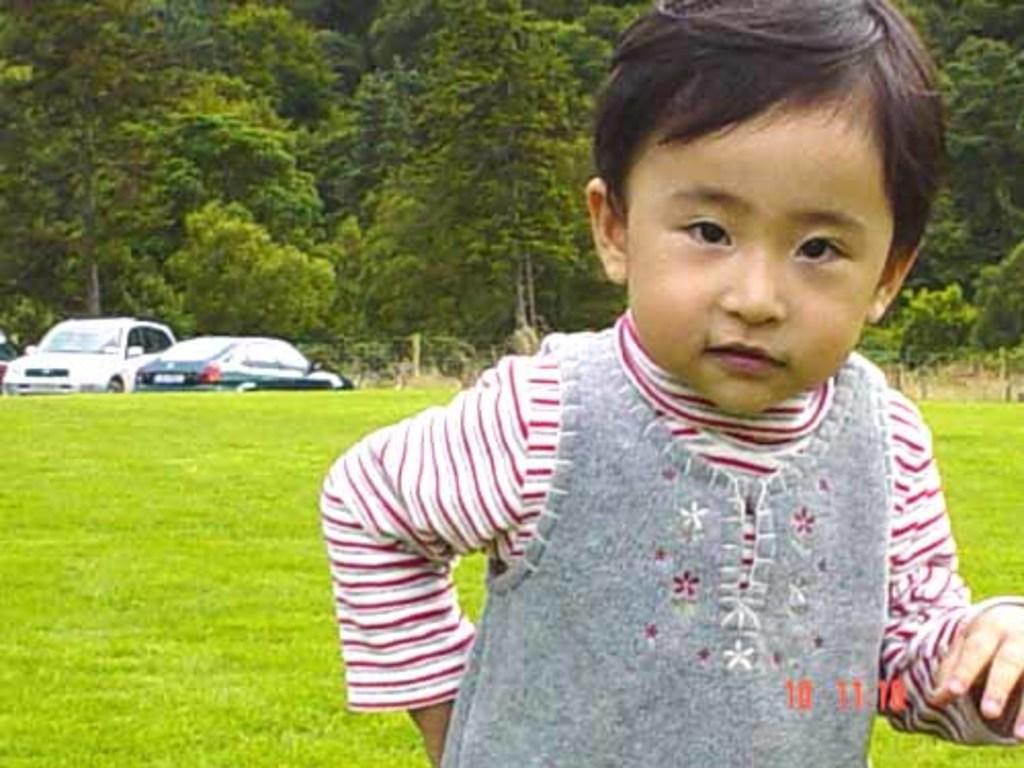In one or two sentences, can you explain what this image depicts? In this picture we can see a boy and some grass is visible on the ground. We can see few vehicles and trees in the background. 